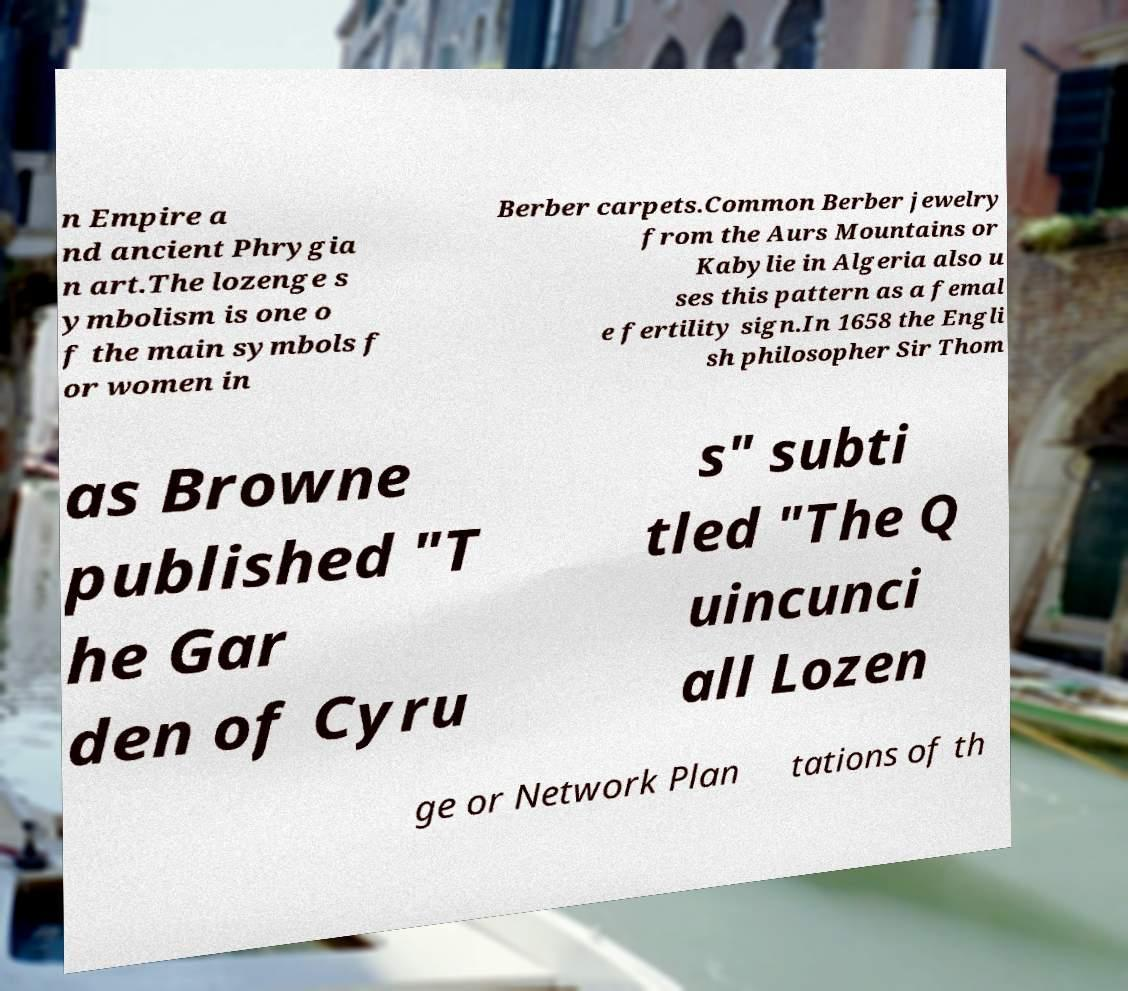There's text embedded in this image that I need extracted. Can you transcribe it verbatim? n Empire a nd ancient Phrygia n art.The lozenge s ymbolism is one o f the main symbols f or women in Berber carpets.Common Berber jewelry from the Aurs Mountains or Kabylie in Algeria also u ses this pattern as a femal e fertility sign.In 1658 the Engli sh philosopher Sir Thom as Browne published "T he Gar den of Cyru s" subti tled "The Q uincunci all Lozen ge or Network Plan tations of th 